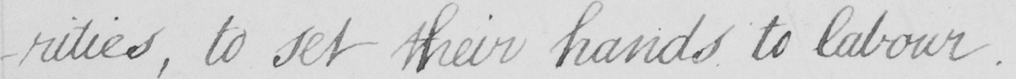Can you tell me what this handwritten text says? -rities , to set their hands to labour . 